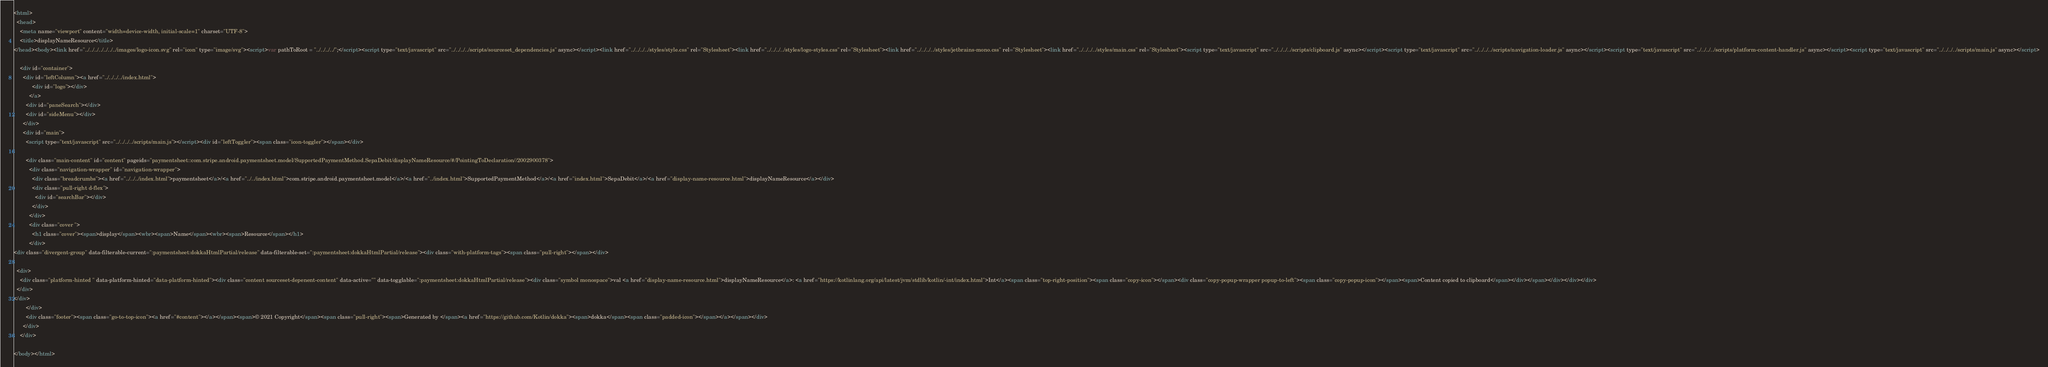<code> <loc_0><loc_0><loc_500><loc_500><_HTML_><html>
  <head>
    <meta name="viewport" content="width=device-width, initial-scale=1" charset="UTF-8">
    <title>displayNameResource</title>
</head><body><link href="../../../../../../../images/logo-icon.svg" rel="icon" type="image/svg"><script>var pathToRoot = "../../../../";</script><script type="text/javascript" src="../../../../scripts/sourceset_dependencies.js" async></script><link href="../../../../styles/style.css" rel="Stylesheet"><link href="../../../../styles/logo-styles.css" rel="Stylesheet"><link href="../../../../styles/jetbrains-mono.css" rel="Stylesheet"><link href="../../../../styles/main.css" rel="Stylesheet"><script type="text/javascript" src="../../../../scripts/clipboard.js" async></script><script type="text/javascript" src="../../../../scripts/navigation-loader.js" async></script><script type="text/javascript" src="../../../../scripts/platform-content-handler.js" async></script><script type="text/javascript" src="../../../../scripts/main.js" async></script>
  
    <div id="container">
      <div id="leftColumn"><a href="../../../../index.html">
            <div id="logo"></div>
          </a>
        <div id="paneSearch"></div>
        <div id="sideMenu"></div>
      </div>
      <div id="main">
        <script type="text/javascript" src="../../../../scripts/main.js"></script><div id="leftToggler"><span class="icon-toggler"></span></div>

        <div class="main-content" id="content" pageids="paymentsheet::com.stripe.android.paymentsheet.model/SupportedPaymentMethod.SepaDebit/displayNameResource/#/PointingToDeclaration//2002900378">
          <div class="navigation-wrapper" id="navigation-wrapper">
            <div class="breadcrumbs"><a href="../../../index.html">paymentsheet</a>/<a href="../../index.html">com.stripe.android.paymentsheet.model</a>/<a href="../index.html">SupportedPaymentMethod</a>/<a href="index.html">SepaDebit</a>/<a href="display-name-resource.html">displayNameResource</a></div>
            <div class="pull-right d-flex">
              <div id="searchBar"></div>
            </div>
          </div>
          <div class="cover ">
            <h1 class="cover"><span>display</span><wbr><span>Name</span><wbr><span>Resource</span></h1>
          </div>
<div class="divergent-group" data-filterable-current=":paymentsheet:dokkaHtmlPartial/release" data-filterable-set=":paymentsheet:dokkaHtmlPartial/release"><div class="with-platform-tags"><span class="pull-right"></span></div>

  <div>
    <div class="platform-hinted " data-platform-hinted="data-platform-hinted"><div class="content sourceset-depenent-content" data-active="" data-togglable=":paymentsheet:dokkaHtmlPartial/release"><div class="symbol monospace">val <a href="display-name-resource.html">displayNameResource</a>: <a href="https://kotlinlang.org/api/latest/jvm/stdlib/kotlin/-int/index.html">Int</a><span class="top-right-position"><span class="copy-icon"></span><div class="copy-popup-wrapper popup-to-left"><span class="copy-popup-icon"></span><span>Content copied to clipboard</span></div></span></div></div></div>
  </div>
</div>
        </div>
        <div class="footer"><span class="go-to-top-icon"><a href="#content"></a></span><span>© 2021 Copyright</span><span class="pull-right"><span>Generated by </span><a href="https://github.com/Kotlin/dokka"><span>dokka</span><span class="padded-icon"></span></a></span></div>
      </div>
    </div>
  
</body></html>


</code> 